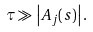Convert formula to latex. <formula><loc_0><loc_0><loc_500><loc_500>\tau \gg \left | A _ { j } ( s ) \right | .</formula> 